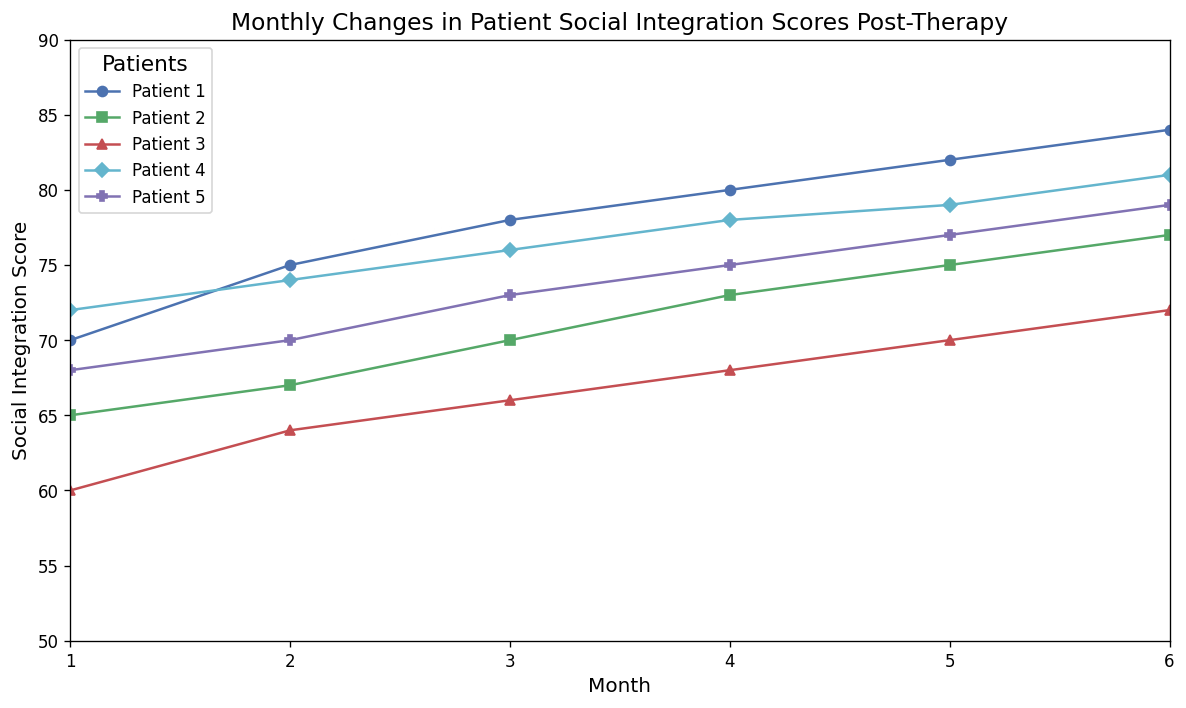What is the general trend for Patient 1's Social Integration Scores over the 6 months? Looking at Patient 1's line, we see a steady increase each month: 70 -> 75 -> 78 -> 80 -> 82 -> 84. The general trend is an upward trend in their scores every month.
Answer: Upward Which patient shows the highest Social Integration Score in Month 6? Examining the values at Month 6 across all patients, Patient 1 has the highest score at 84.
Answer: Patient 1 Between which months did Patient 3 experience the largest increase in Social Integration Score? Comparing month-to-month changes for Patient 3: 
- Month 1 to 2: 64 - 60 = 4 
- Month 2 to 3: 66 - 64 = 2 
- Month 3 to 4: 68 - 66 = 2 
- Month 4 to 5: 70 - 68 = 2 
- Month 5 to 6: 72 - 70 = 2 
The largest increase is from Month 1 to Month 2 (an increase of 4).
Answer: Month 1 to Month 2 Which patient had the most consistent increase in their Social Integration Scores throughout the 6 months? By inspecting the trend lines, Patient 1's scores increase steadily without any decrease or fluctuation: 70 -> 75 -> 78 -> 80 -> 82 -> 84. Patient 4's scores also consistently increase but start at a higher score.
Answer: Patient 1 What is the range of Social Integration Scores for Patient 2 over the 6 months? The minimum score for Patient 2 is 65 (Month 1) and the maximum score is 77 (Month 6). The range is calculated as 77 - 65.
Answer: 12 Which patients had the same Social Integration Score at any point during the 6 months? By examining the data points, Patient 4 and Patient 2 both had a Social Integration Score of 75 in Month 5 and Month 6, respectively.
Answer: Patients 4 and 2 How much did Patient 5's Social Integration Score change from Month 2 to Month 3? Patient 5's score in Month 2 was 70 and in Month 3 it was 73. The change is calculated as 73 - 70.
Answer: 3 Which patient started with the lowest Social Integration Score in Month 1? Observing the scores at Month 1, Patient 3 started with the lowest score of 60.
Answer: Patient 3 Among all patients, what is the average Social Integration Score in Month 3? Summing up the scores in Month 3: (78 + 70 + 66 + 76 + 73) = 363. Dividing by the number of patients (5), the average score is 363/5.
Answer: 72.6 